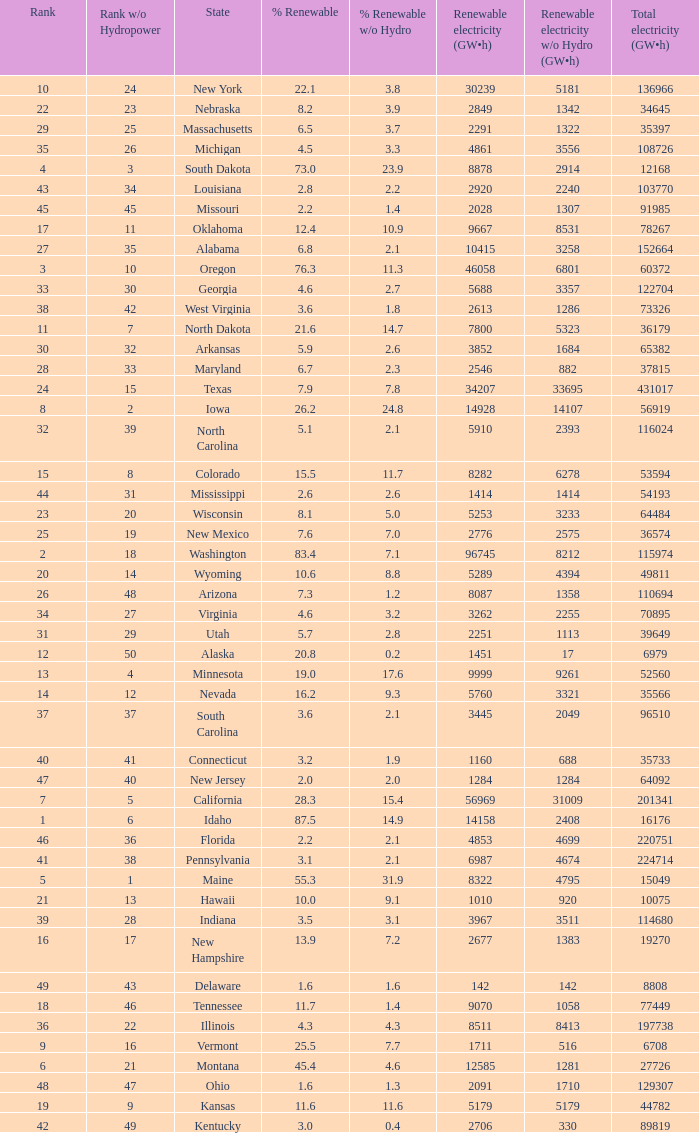What is the percentage of renewable electricity without hydrogen power in the state of South Dakota? 23.9. 